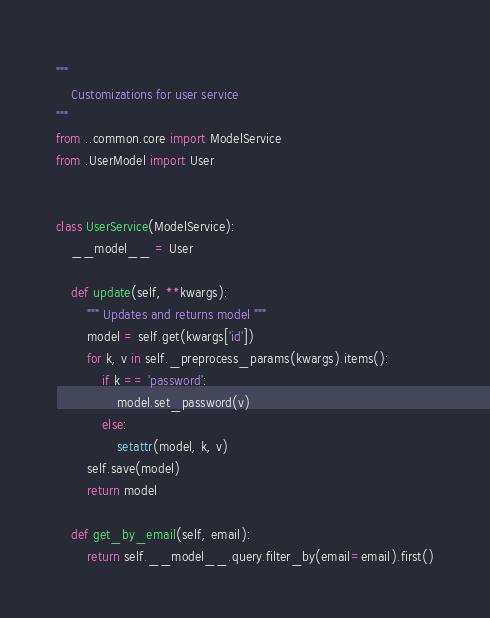<code> <loc_0><loc_0><loc_500><loc_500><_Python_>"""
    Customizations for user service
"""
from ..common.core import ModelService
from .UserModel import User


class UserService(ModelService):
    __model__ = User

    def update(self, **kwargs):
        """ Updates and returns model """
        model = self.get(kwargs['id'])
        for k, v in self._preprocess_params(kwargs).items():
            if k == 'password':
                model.set_password(v)
            else:
                setattr(model, k, v)
        self.save(model)
        return model

    def get_by_email(self, email):
        return self.__model__.query.filter_by(email=email).first()
</code> 